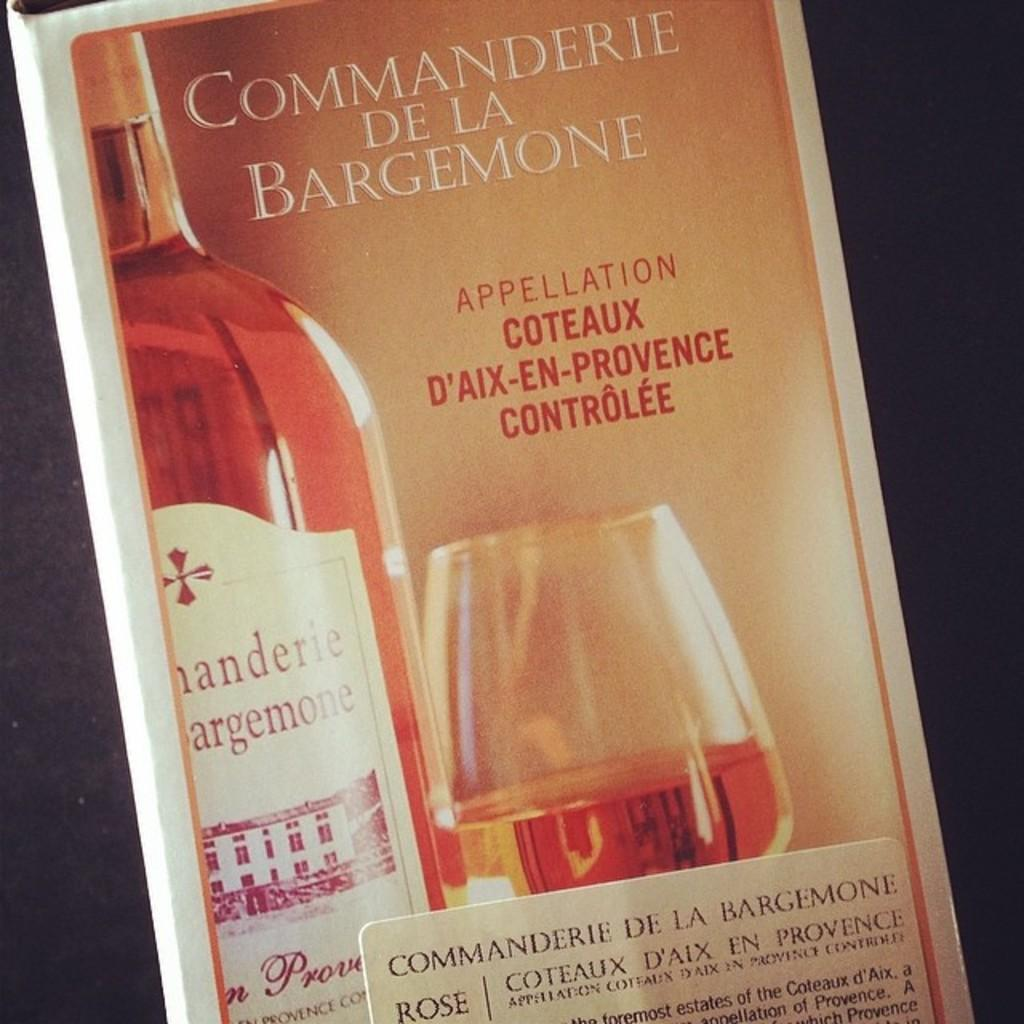<image>
Relay a brief, clear account of the picture shown. An advertisement for Commanderie de la Bargemone rose. 